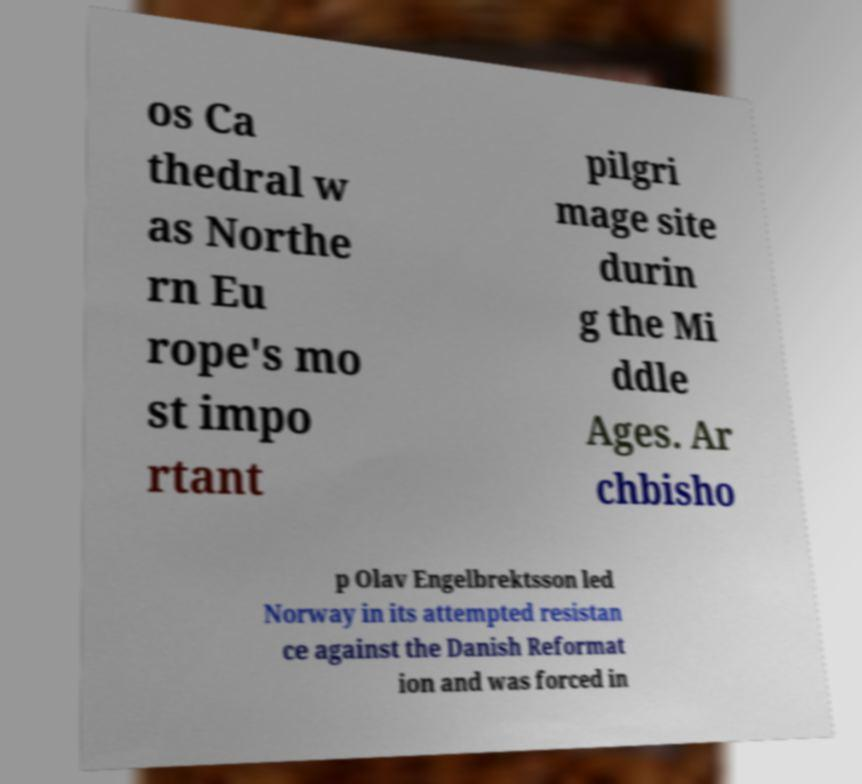What messages or text are displayed in this image? I need them in a readable, typed format. os Ca thedral w as Northe rn Eu rope's mo st impo rtant pilgri mage site durin g the Mi ddle Ages. Ar chbisho p Olav Engelbrektsson led Norway in its attempted resistan ce against the Danish Reformat ion and was forced in 